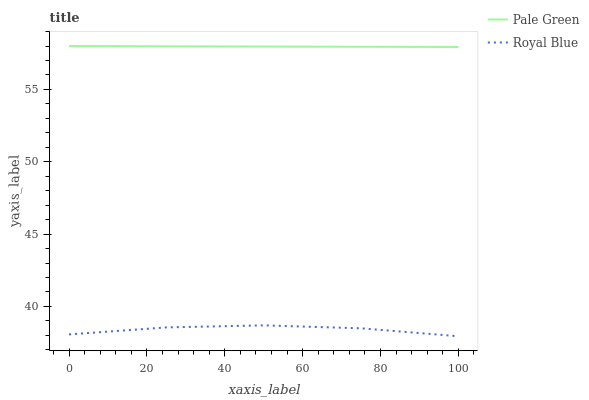Does Pale Green have the minimum area under the curve?
Answer yes or no. No. Is Pale Green the roughest?
Answer yes or no. No. Does Pale Green have the lowest value?
Answer yes or no. No. Is Royal Blue less than Pale Green?
Answer yes or no. Yes. Is Pale Green greater than Royal Blue?
Answer yes or no. Yes. Does Royal Blue intersect Pale Green?
Answer yes or no. No. 